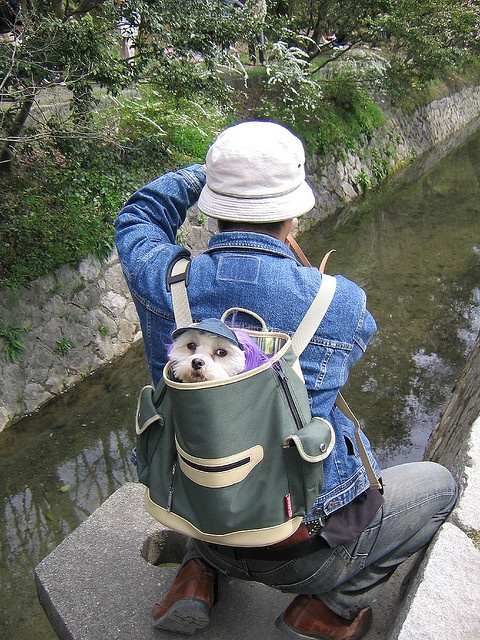Describe the objects in this image and their specific colors. I can see people in black, gray, white, and darkgray tones, backpack in black, gray, lightgray, and darkgray tones, and dog in black, lightgray, darkgray, and gray tones in this image. 